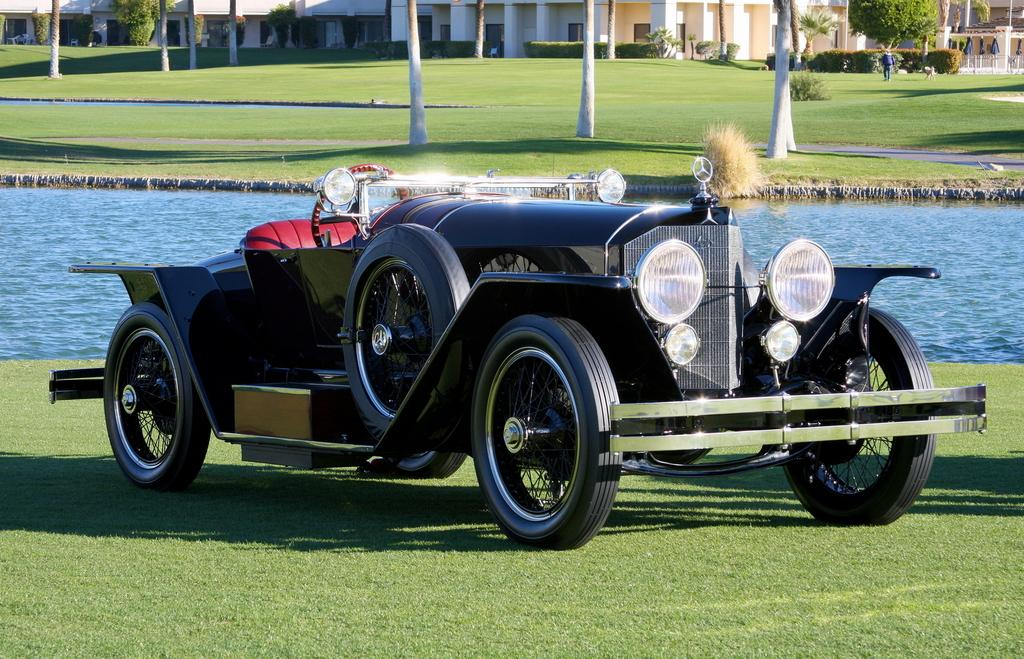What is the main subject of the image? The main subject of the image is a car on the grass. What can be seen beside the car? There is water beside the car. What is visible in the background of the image? Trees, houses, and people are visible in the background of the image. What type of question is being asked in the image? There is no question being asked in the image; it is a visual representation of a car on the grass with water, trees, houses, and people in the background. 